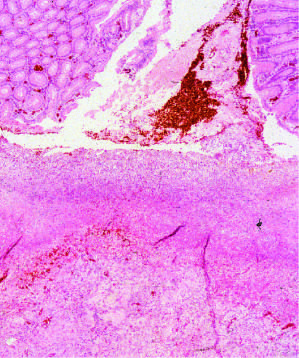s the necrotic ulcer base composed of granulation tissue overlaid by degraded blood?
Answer the question using a single word or phrase. Yes 